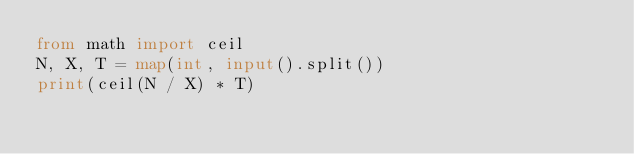Convert code to text. <code><loc_0><loc_0><loc_500><loc_500><_Python_>from math import ceil
N, X, T = map(int, input().split())
print(ceil(N / X) * T)
</code> 